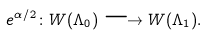Convert formula to latex. <formula><loc_0><loc_0><loc_500><loc_500>e ^ { \alpha / 2 } \colon W ( \Lambda _ { 0 } ) \longrightarrow W ( \Lambda _ { 1 } ) .</formula> 